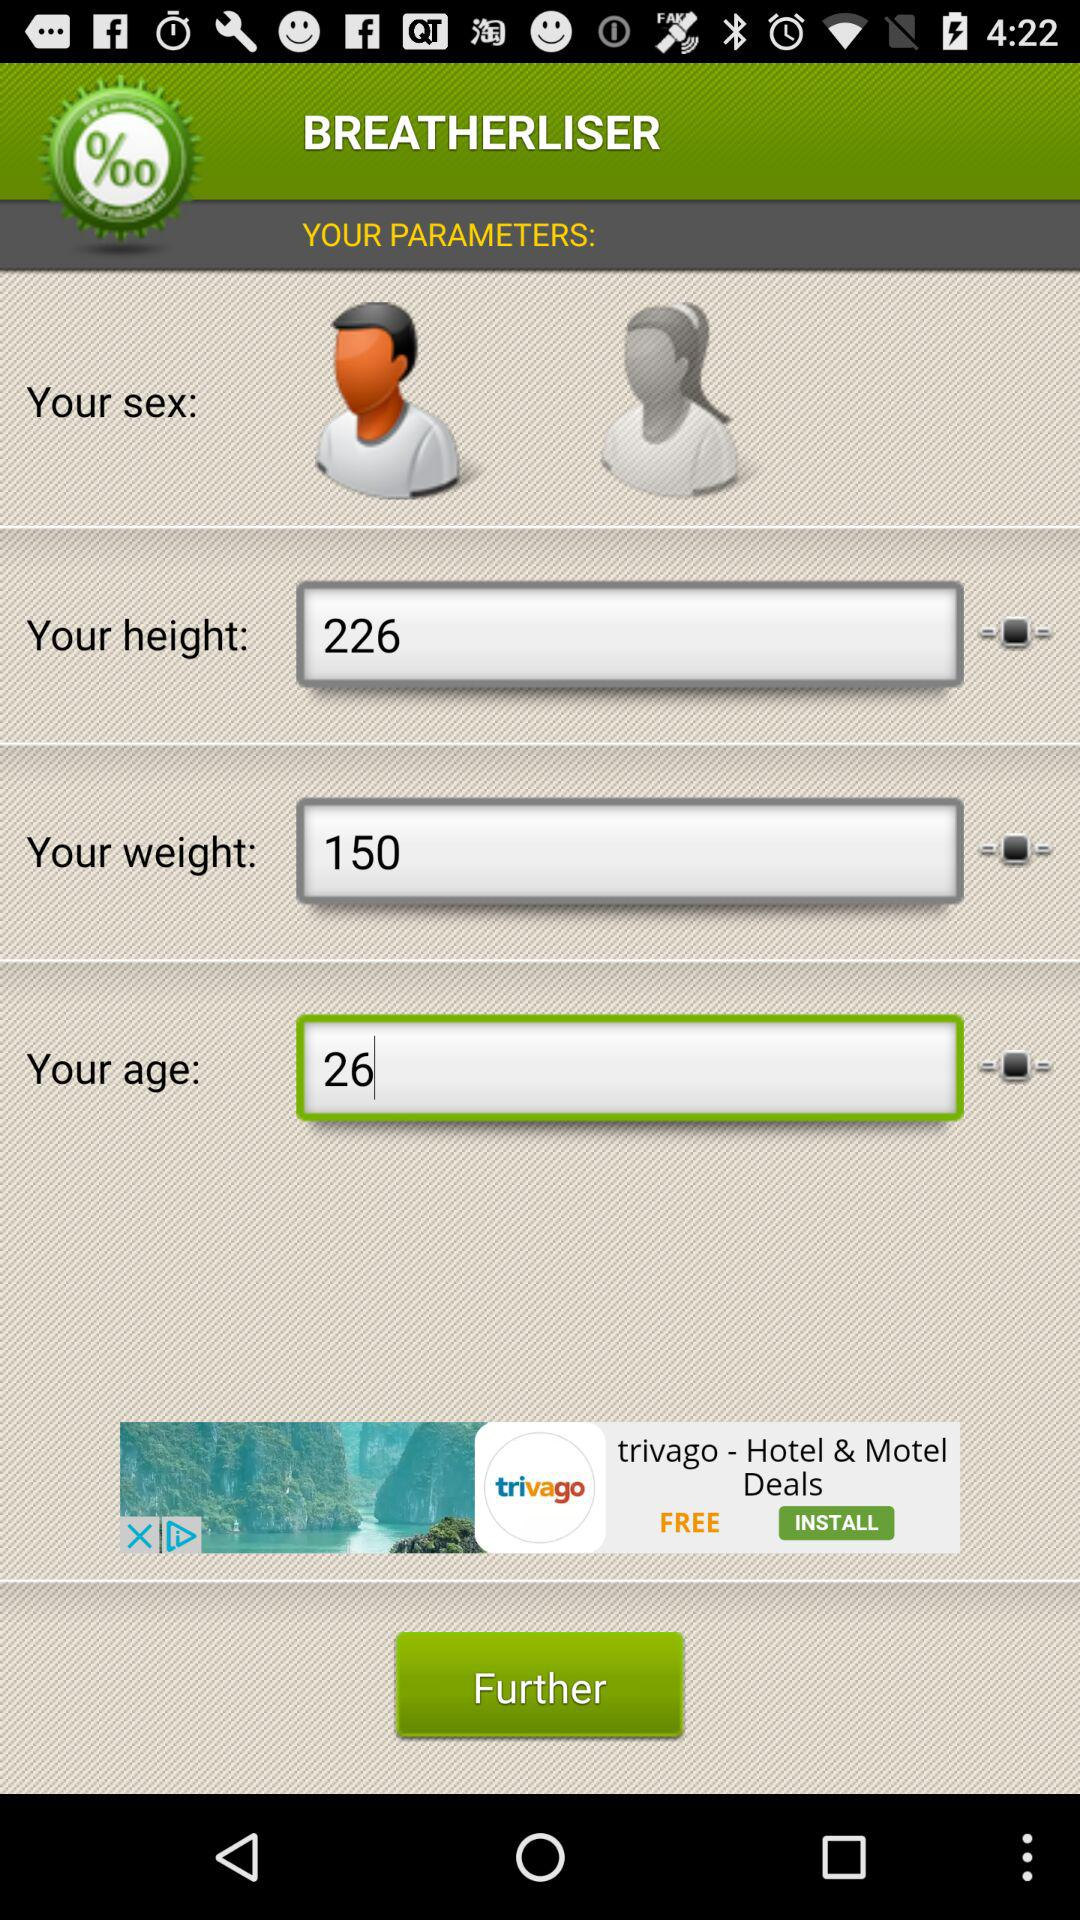Which gender is selected? The selected gender is male. 